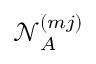<formula> <loc_0><loc_0><loc_500><loc_500>\mathcal { N } _ { A } ^ { ( m j ) }</formula> 